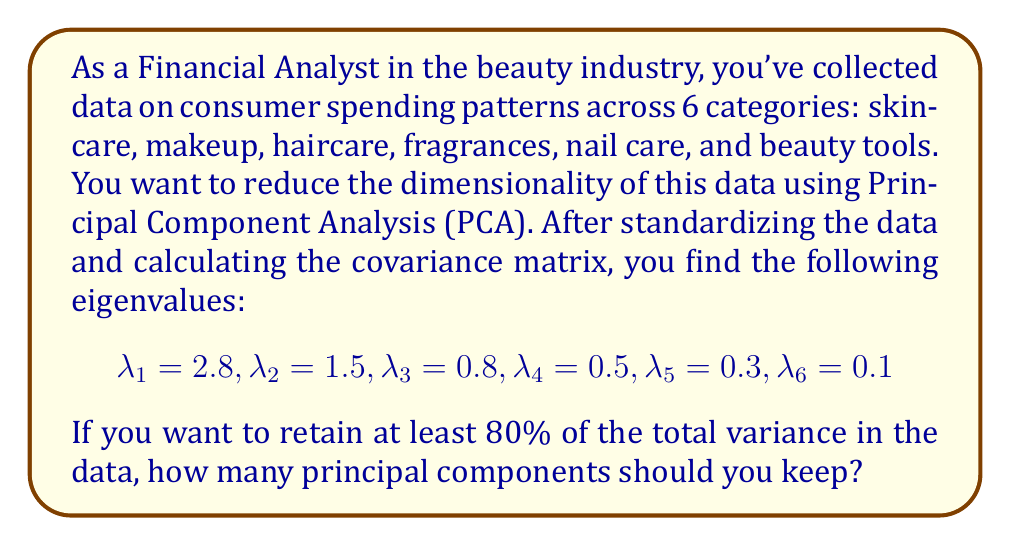Teach me how to tackle this problem. To determine the number of principal components to retain, we need to calculate the proportion of variance explained by each component and then find the cumulative proportion until we reach or exceed 80%. Here's the step-by-step process:

1. Calculate the total variance:
   $$\text{Total Variance} = \sum_{i=1}^6 \lambda_i = 2.8 + 1.5 + 0.8 + 0.5 + 0.3 + 0.1 = 6.0$$

2. Calculate the proportion of variance explained by each component:
   $$\text{Proportion}_i = \frac{\lambda_i}{\text{Total Variance}}$$

   For PC1: $\frac{2.8}{6.0} = 0.4667$ or 46.67%
   For PC2: $\frac{1.5}{6.0} = 0.2500$ or 25.00%
   For PC3: $\frac{0.8}{6.0} = 0.1333$ or 13.33%
   For PC4: $\frac{0.5}{6.0} = 0.0833$ or 8.33%
   For PC5: $\frac{0.3}{6.0} = 0.0500$ or 5.00%
   For PC6: $\frac{0.1}{6.0} = 0.0167$ or 1.67%

3. Calculate the cumulative proportion of variance:
   PC1: 46.67%
   PC1 + PC2: 46.67% + 25.00% = 71.67%
   PC1 + PC2 + PC3: 71.67% + 13.33% = 85.00%

4. Determine the number of components needed to reach at least 80%:
   We see that the first two components explain 71.67% of the variance, which is less than 80%.
   Adding the third component brings the total to 85.00%, which exceeds 80%.

Therefore, we need to retain 3 principal components to explain at least 80% of the total variance in the consumer spending patterns data.
Answer: 3 principal components 